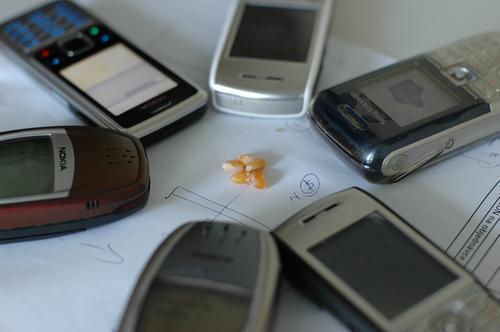What does the item in the middle of the phones look like?
Select the accurate response from the four choices given to answer the question.
Options: Umbrella, marshmallow, jelly beans, baby. Jelly beans. 